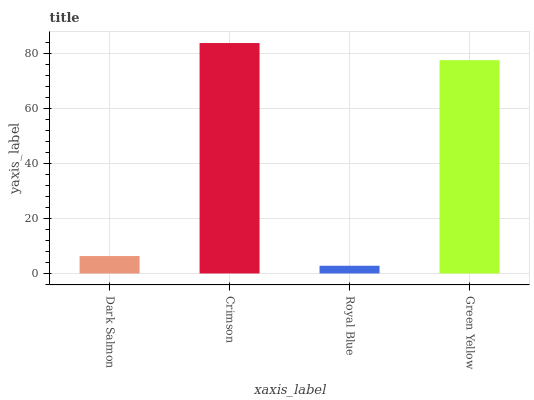Is Royal Blue the minimum?
Answer yes or no. Yes. Is Crimson the maximum?
Answer yes or no. Yes. Is Crimson the minimum?
Answer yes or no. No. Is Royal Blue the maximum?
Answer yes or no. No. Is Crimson greater than Royal Blue?
Answer yes or no. Yes. Is Royal Blue less than Crimson?
Answer yes or no. Yes. Is Royal Blue greater than Crimson?
Answer yes or no. No. Is Crimson less than Royal Blue?
Answer yes or no. No. Is Green Yellow the high median?
Answer yes or no. Yes. Is Dark Salmon the low median?
Answer yes or no. Yes. Is Dark Salmon the high median?
Answer yes or no. No. Is Royal Blue the low median?
Answer yes or no. No. 